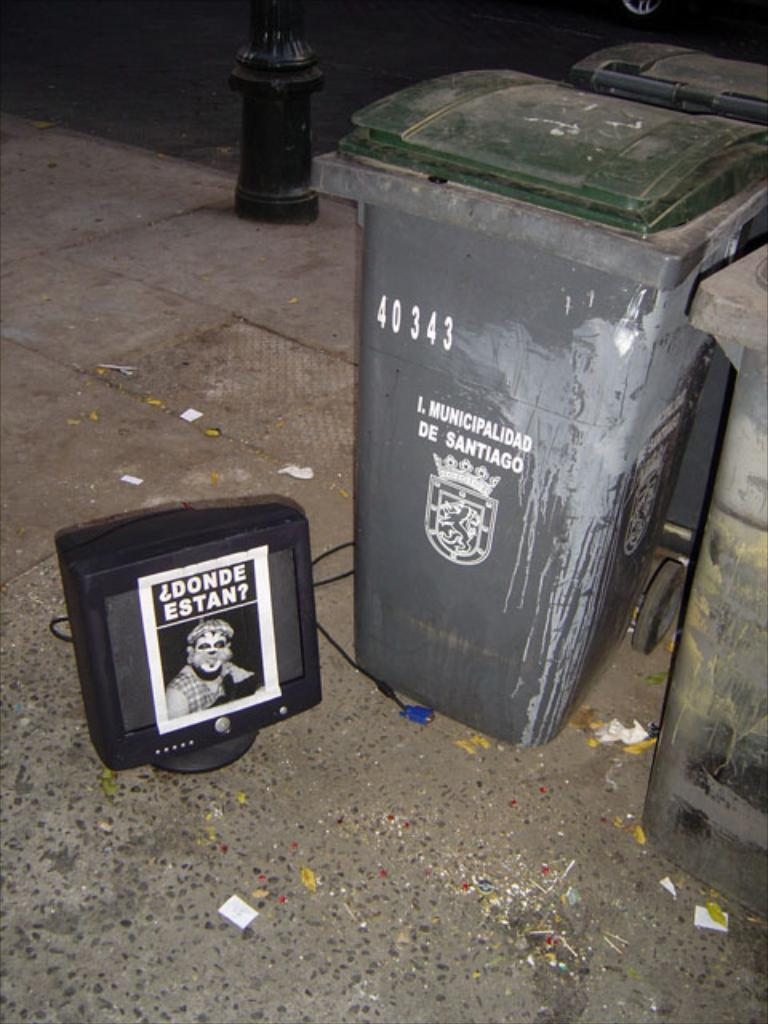<image>
Describe the image concisely. Garbage can which has the numbers 40343 on it. 